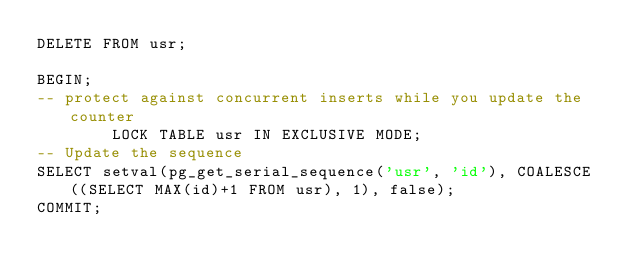<code> <loc_0><loc_0><loc_500><loc_500><_SQL_>DELETE FROM usr;

BEGIN;
-- protect against concurrent inserts while you update the counter
        LOCK TABLE usr IN EXCLUSIVE MODE;
-- Update the sequence
SELECT setval(pg_get_serial_sequence('usr', 'id'), COALESCE((SELECT MAX(id)+1 FROM usr), 1), false);
COMMIT;
</code> 